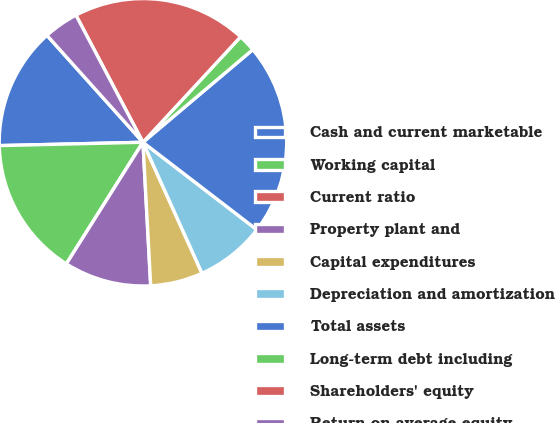<chart> <loc_0><loc_0><loc_500><loc_500><pie_chart><fcel>Cash and current marketable<fcel>Working capital<fcel>Current ratio<fcel>Property plant and<fcel>Capital expenditures<fcel>Depreciation and amortization<fcel>Total assets<fcel>Long-term debt including<fcel>Shareholders' equity<fcel>Return on average equity<nl><fcel>13.72%<fcel>15.68%<fcel>0.0%<fcel>9.8%<fcel>5.88%<fcel>7.84%<fcel>21.56%<fcel>1.96%<fcel>19.6%<fcel>3.92%<nl></chart> 